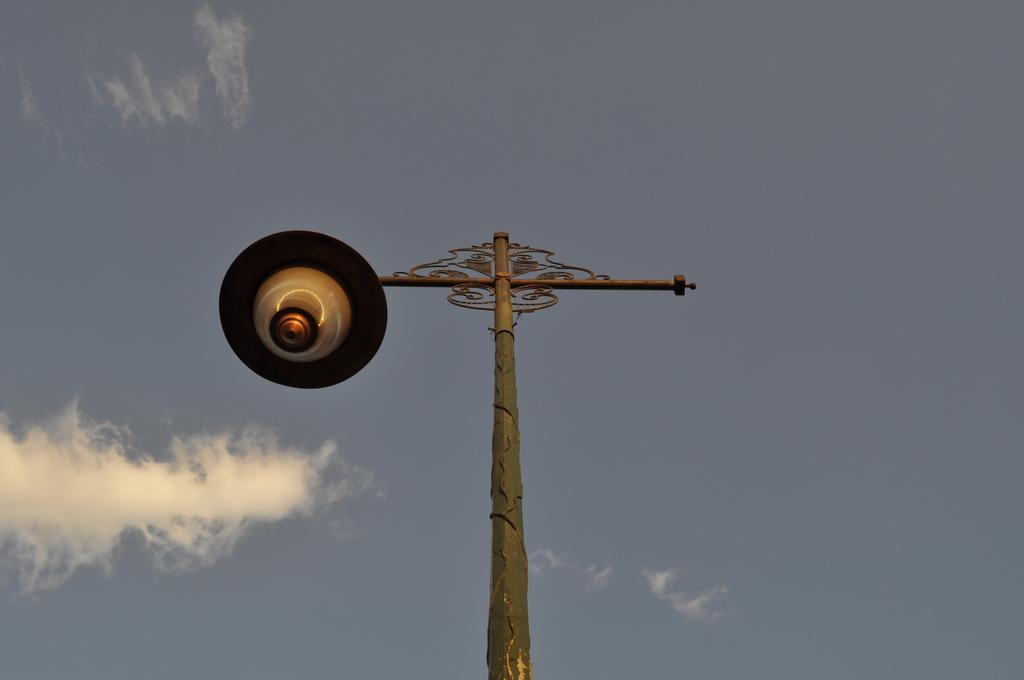What is the main object in the image? There is a street lamp in the image. How is the street lamp supported? The street lamp is attached to a pole. What can be seen in the background of the image? The sky is visible in the image. How would you describe the weather based on the appearance of the sky? The sky appears cloudy, which might suggest overcast or cloudy weather. What type of canvas is being used to paint the street lamp in the image? There is no canvas or painting present in the image; it is a photograph of a real street lamp. 